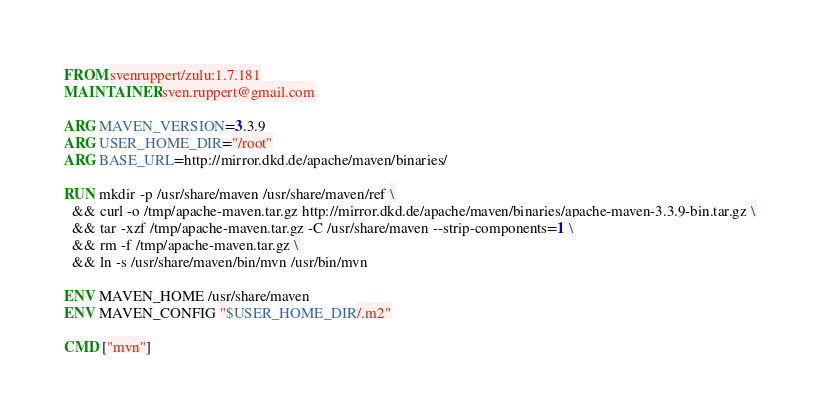Convert code to text. <code><loc_0><loc_0><loc_500><loc_500><_Dockerfile_>FROM svenruppert/zulu:1.7.181
MAINTAINER sven.ruppert@gmail.com

ARG MAVEN_VERSION=3.3.9
ARG USER_HOME_DIR="/root"
ARG BASE_URL=http://mirror.dkd.de/apache/maven/binaries/

RUN mkdir -p /usr/share/maven /usr/share/maven/ref \
  && curl -o /tmp/apache-maven.tar.gz http://mirror.dkd.de/apache/maven/binaries/apache-maven-3.3.9-bin.tar.gz \
  && tar -xzf /tmp/apache-maven.tar.gz -C /usr/share/maven --strip-components=1 \
  && rm -f /tmp/apache-maven.tar.gz \
  && ln -s /usr/share/maven/bin/mvn /usr/bin/mvn

ENV MAVEN_HOME /usr/share/maven
ENV MAVEN_CONFIG "$USER_HOME_DIR/.m2"

CMD ["mvn"]</code> 